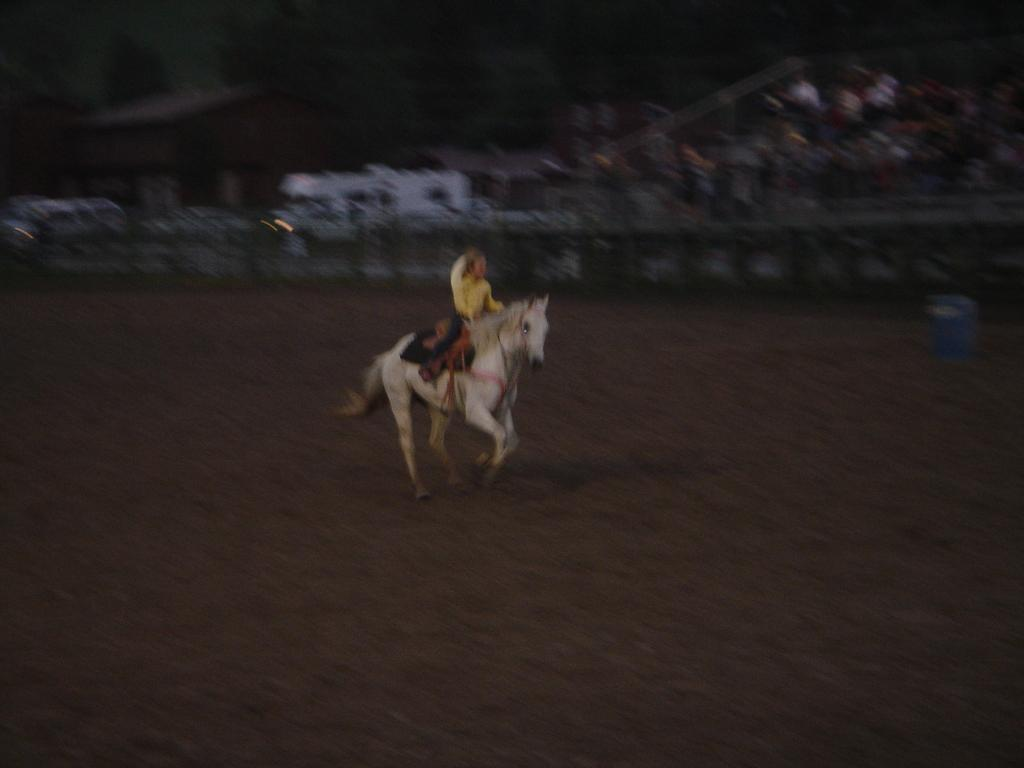What is the main subject of the image? There is a person riding a horse in the image. What time of day is the image taken? The image is taken during night. What can be seen in the background of the image? There is a fence, a crowd, a house, and trees in the background of the image. Where is the mailbox located in the image? There is no mailbox present in the image. What type of goose can be seen interacting with the person riding the horse in the image? There is no goose present in the image; it only features a person riding a horse and the background elements. 